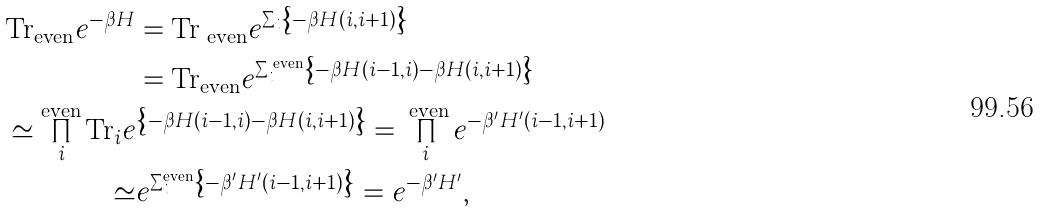<formula> <loc_0><loc_0><loc_500><loc_500>\text {Tr} _ { \text {even} } e ^ { - \beta H } & = \text {Tr} _ { \text { even} } e ^ { \sum _ { i } \left \{ - \beta H ( i , i + 1 ) \right \} } \\ & = \text {Tr} _ { \text {even} } e ^ { \sum _ { i } ^ { \text { even} } \left \{ - \beta H ( i - 1 , i ) - \beta H ( i , i + 1 ) \right \} } \\ \simeq \prod _ { i } ^ { \text {even} } \text {Tr} _ { i } e & ^ { \left \{ - \beta H ( i - 1 , i ) - \beta H ( i , i + 1 ) \right \} } = \prod _ { i } ^ { \text { even} } e ^ { - \beta ^ { \prime } H ^ { \prime } ( i - 1 , i + 1 ) } \\ \simeq & e ^ { \sum _ { i } ^ { \text {even} } \left \{ - \beta ^ { \prime } H ^ { \prime } ( i - 1 , i + 1 ) \right \} } = e ^ { - \beta ^ { \prime } H ^ { \prime } } ,</formula> 